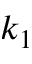Convert formula to latex. <formula><loc_0><loc_0><loc_500><loc_500>k _ { 1 }</formula> 